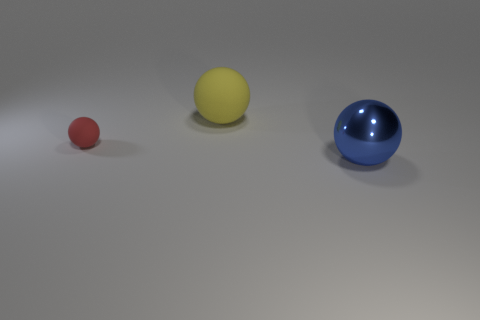Can you describe the colors and sizes of the balls in relation to each other? Certainly! There are three balls arranged from left to right, exhibiting a gradient in size and distinct colors. The one on the left is a small red ball, the middle is a medium-sized yellow ball, and the right is a larger blue ball. The red is clearly the smallest, the yellow is medium in size, and the blue is the largest, displaying a visually satisfying progression of sizes and colors. 